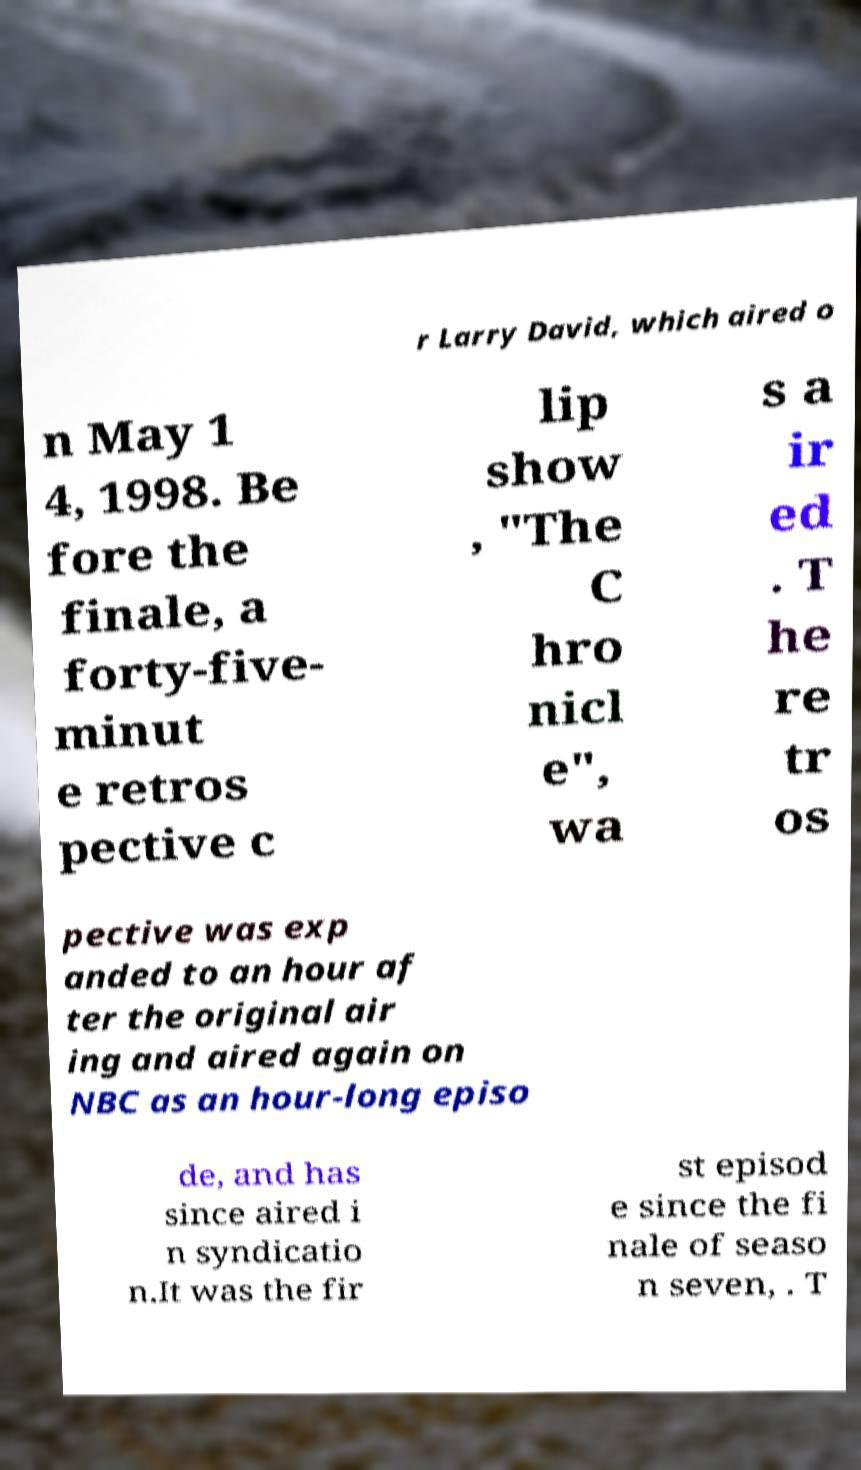There's text embedded in this image that I need extracted. Can you transcribe it verbatim? r Larry David, which aired o n May 1 4, 1998. Be fore the finale, a forty-five- minut e retros pective c lip show , "The C hro nicl e", wa s a ir ed . T he re tr os pective was exp anded to an hour af ter the original air ing and aired again on NBC as an hour-long episo de, and has since aired i n syndicatio n.It was the fir st episod e since the fi nale of seaso n seven, . T 